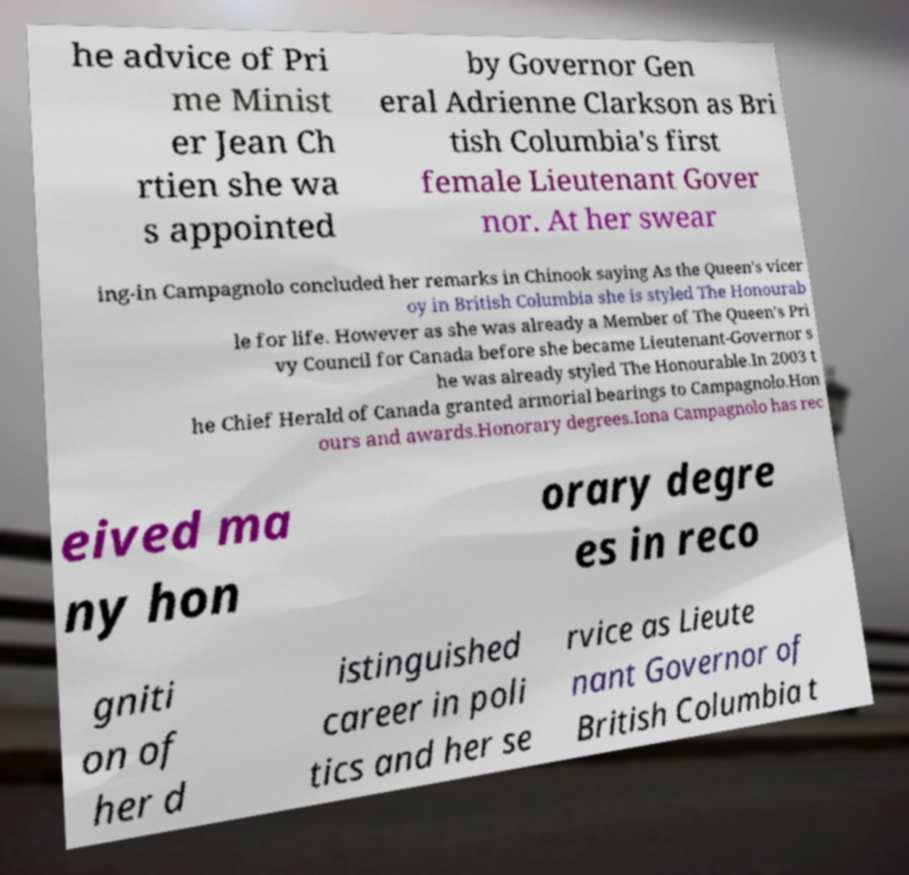Please read and relay the text visible in this image. What does it say? he advice of Pri me Minist er Jean Ch rtien she wa s appointed by Governor Gen eral Adrienne Clarkson as Bri tish Columbia's first female Lieutenant Gover nor. At her swear ing-in Campagnolo concluded her remarks in Chinook saying As the Queen's vicer oy in British Columbia she is styled The Honourab le for life. However as she was already a Member of The Queen's Pri vy Council for Canada before she became Lieutenant-Governor s he was already styled The Honourable.In 2003 t he Chief Herald of Canada granted armorial bearings to Campagnolo.Hon ours and awards.Honorary degrees.Iona Campagnolo has rec eived ma ny hon orary degre es in reco gniti on of her d istinguished career in poli tics and her se rvice as Lieute nant Governor of British Columbia t 